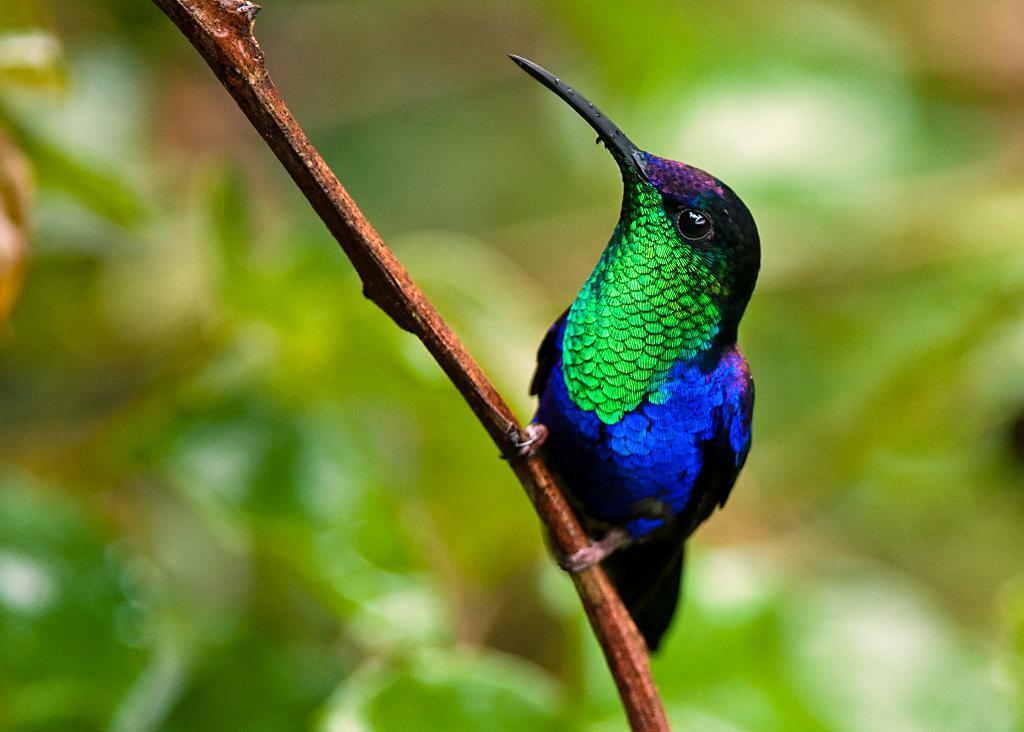Could you give a brief overview of what you see in this image? This is a zoomed in picture. In the center there is a bird seems to be standing on an object which seems to be the branch of a tree. The background of the image is blurry. 